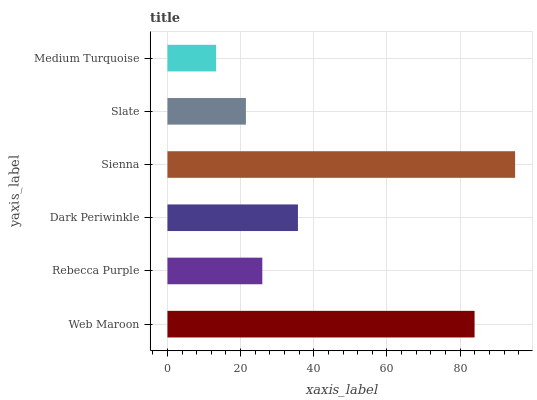Is Medium Turquoise the minimum?
Answer yes or no. Yes. Is Sienna the maximum?
Answer yes or no. Yes. Is Rebecca Purple the minimum?
Answer yes or no. No. Is Rebecca Purple the maximum?
Answer yes or no. No. Is Web Maroon greater than Rebecca Purple?
Answer yes or no. Yes. Is Rebecca Purple less than Web Maroon?
Answer yes or no. Yes. Is Rebecca Purple greater than Web Maroon?
Answer yes or no. No. Is Web Maroon less than Rebecca Purple?
Answer yes or no. No. Is Dark Periwinkle the high median?
Answer yes or no. Yes. Is Rebecca Purple the low median?
Answer yes or no. Yes. Is Medium Turquoise the high median?
Answer yes or no. No. Is Medium Turquoise the low median?
Answer yes or no. No. 